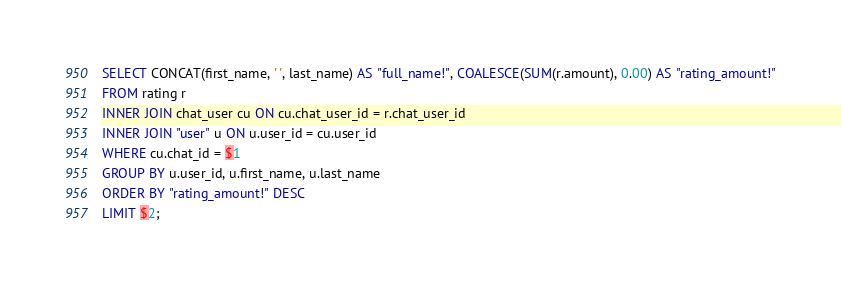<code> <loc_0><loc_0><loc_500><loc_500><_SQL_>SELECT CONCAT(first_name, ' ', last_name) AS "full_name!", COALESCE(SUM(r.amount), 0.00) AS "rating_amount!"
FROM rating r
INNER JOIN chat_user cu ON cu.chat_user_id = r.chat_user_id
INNER JOIN "user" u ON u.user_id = cu.user_id
WHERE cu.chat_id = $1
GROUP BY u.user_id, u.first_name, u.last_name
ORDER BY "rating_amount!" DESC
LIMIT $2;</code> 